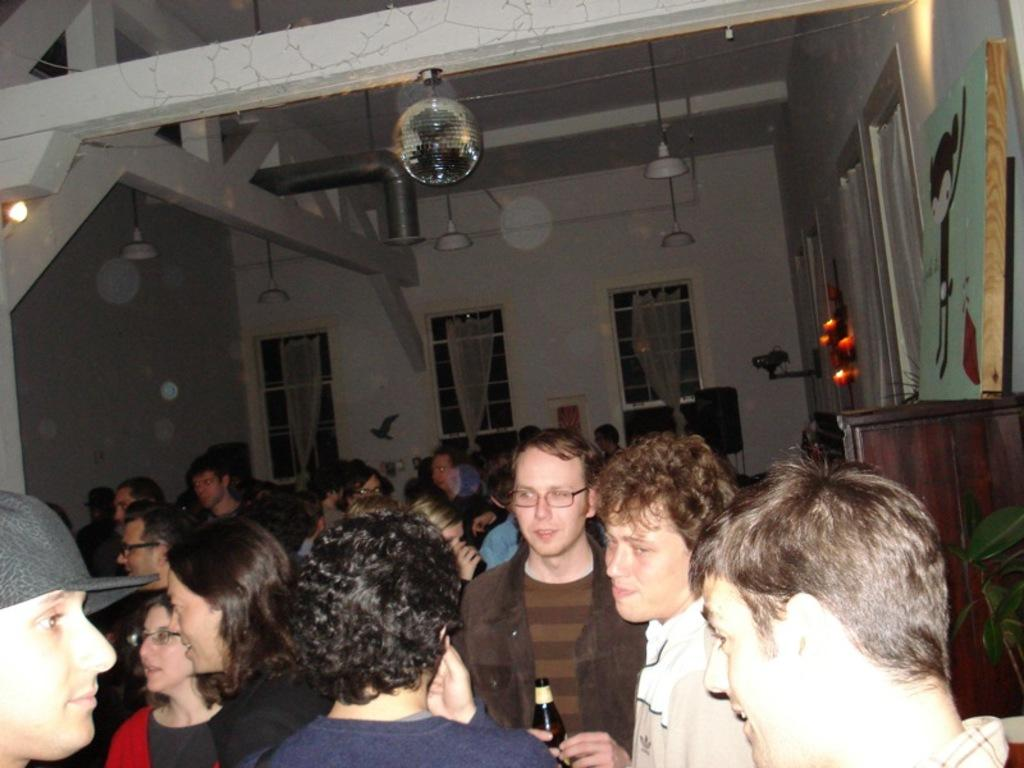What can be found inside the building in the image? There are people inside the building. What allows natural light to enter the building? There are windows in the building. What provides structural support and privacy for the building? There are walls in the building. What helps to illuminate the interior of the building? There are lights in the building. What can be seen around the building in the image? There are objects placed around the building. How many slaves are visible inside the building in the image? There is no mention of slaves in the image, and therefore none can be seen. 